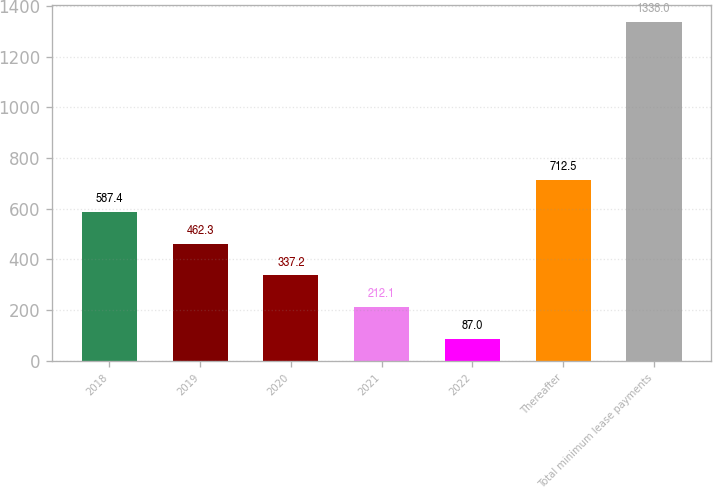Convert chart. <chart><loc_0><loc_0><loc_500><loc_500><bar_chart><fcel>2018<fcel>2019<fcel>2020<fcel>2021<fcel>2022<fcel>Thereafter<fcel>Total minimum lease payments<nl><fcel>587.4<fcel>462.3<fcel>337.2<fcel>212.1<fcel>87<fcel>712.5<fcel>1338<nl></chart> 